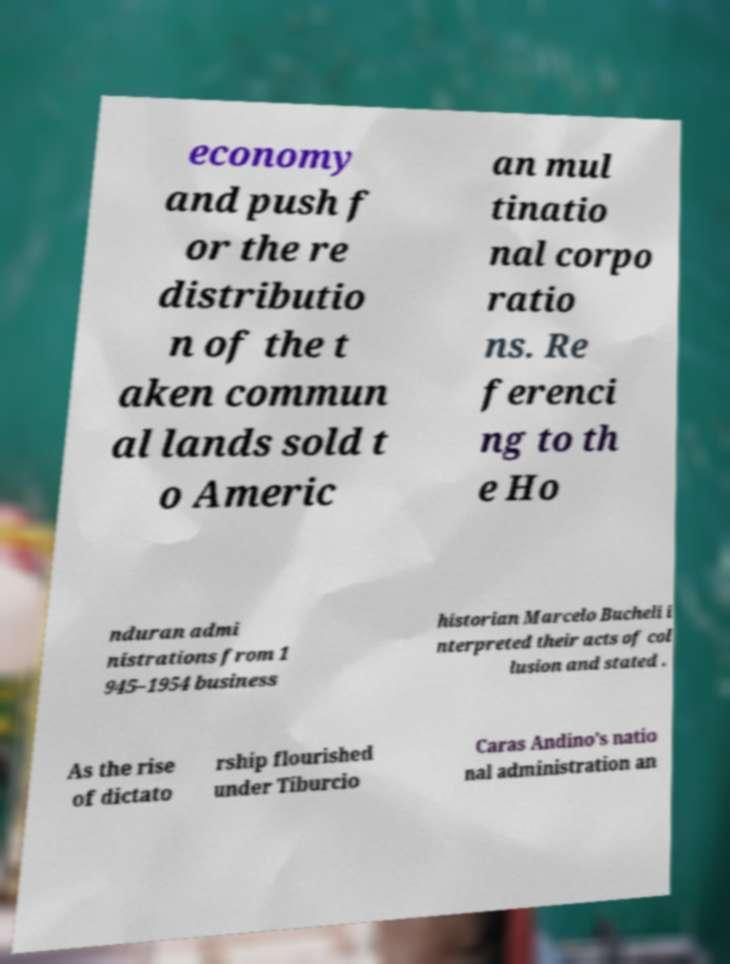Can you read and provide the text displayed in the image?This photo seems to have some interesting text. Can you extract and type it out for me? economy and push f or the re distributio n of the t aken commun al lands sold t o Americ an mul tinatio nal corpo ratio ns. Re ferenci ng to th e Ho nduran admi nistrations from 1 945–1954 business historian Marcelo Bucheli i nterpreted their acts of col lusion and stated . As the rise of dictato rship flourished under Tiburcio Caras Andino's natio nal administration an 